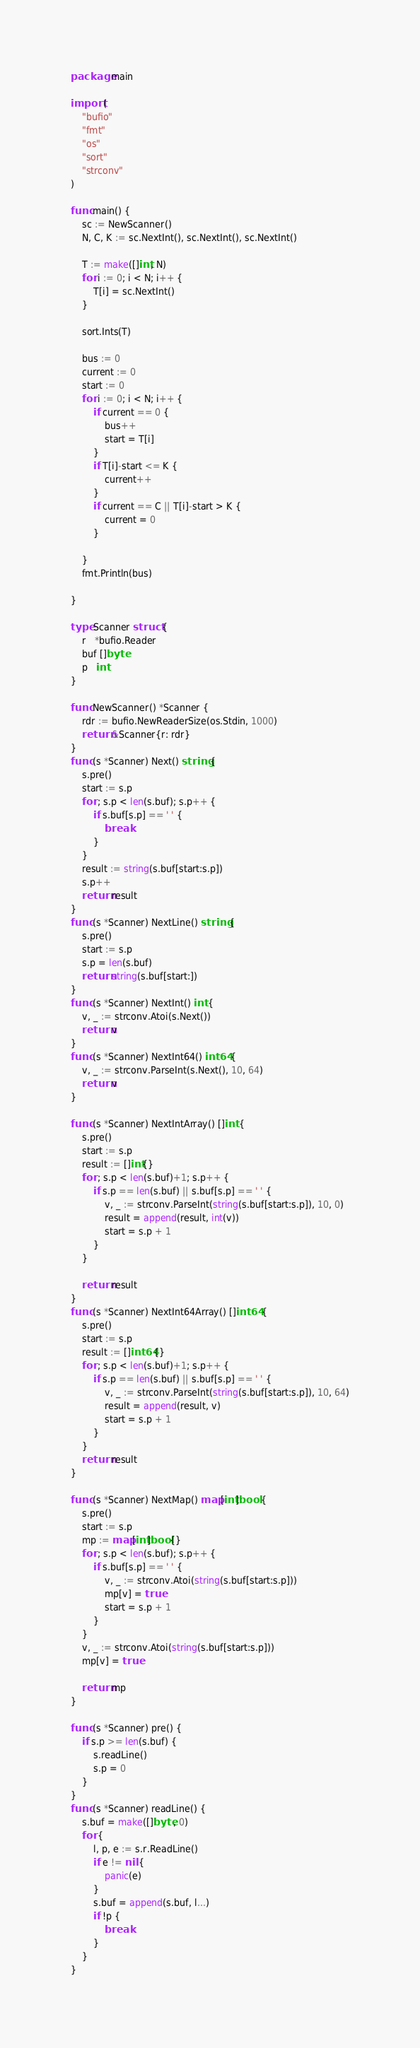<code> <loc_0><loc_0><loc_500><loc_500><_Go_>package main

import (
	"bufio"
	"fmt"
	"os"
	"sort"
	"strconv"
)

func main() {
	sc := NewScanner()
	N, C, K := sc.NextInt(), sc.NextInt(), sc.NextInt()

	T := make([]int, N)
	for i := 0; i < N; i++ {
		T[i] = sc.NextInt()
	}

	sort.Ints(T)

	bus := 0
	current := 0
	start := 0
	for i := 0; i < N; i++ {
		if current == 0 {
			bus++
			start = T[i]
		}
		if T[i]-start <= K {
			current++
		}
		if current == C || T[i]-start > K {
			current = 0
		}

	}
	fmt.Println(bus)

}

type Scanner struct {
	r   *bufio.Reader
	buf []byte
	p   int
}

func NewScanner() *Scanner {
	rdr := bufio.NewReaderSize(os.Stdin, 1000)
	return &Scanner{r: rdr}
}
func (s *Scanner) Next() string {
	s.pre()
	start := s.p
	for ; s.p < len(s.buf); s.p++ {
		if s.buf[s.p] == ' ' {
			break
		}
	}
	result := string(s.buf[start:s.p])
	s.p++
	return result
}
func (s *Scanner) NextLine() string {
	s.pre()
	start := s.p
	s.p = len(s.buf)
	return string(s.buf[start:])
}
func (s *Scanner) NextInt() int {
	v, _ := strconv.Atoi(s.Next())
	return v
}
func (s *Scanner) NextInt64() int64 {
	v, _ := strconv.ParseInt(s.Next(), 10, 64)
	return v
}

func (s *Scanner) NextIntArray() []int {
	s.pre()
	start := s.p
	result := []int{}
	for ; s.p < len(s.buf)+1; s.p++ {
		if s.p == len(s.buf) || s.buf[s.p] == ' ' {
			v, _ := strconv.ParseInt(string(s.buf[start:s.p]), 10, 0)
			result = append(result, int(v))
			start = s.p + 1
		}
	}

	return result
}
func (s *Scanner) NextInt64Array() []int64 {
	s.pre()
	start := s.p
	result := []int64{}
	for ; s.p < len(s.buf)+1; s.p++ {
		if s.p == len(s.buf) || s.buf[s.p] == ' ' {
			v, _ := strconv.ParseInt(string(s.buf[start:s.p]), 10, 64)
			result = append(result, v)
			start = s.p + 1
		}
	}
	return result
}

func (s *Scanner) NextMap() map[int]bool {
	s.pre()
	start := s.p
	mp := map[int]bool{}
	for ; s.p < len(s.buf); s.p++ {
		if s.buf[s.p] == ' ' {
			v, _ := strconv.Atoi(string(s.buf[start:s.p]))
			mp[v] = true
			start = s.p + 1
		}
	}
	v, _ := strconv.Atoi(string(s.buf[start:s.p]))
	mp[v] = true

	return mp
}

func (s *Scanner) pre() {
	if s.p >= len(s.buf) {
		s.readLine()
		s.p = 0
	}
}
func (s *Scanner) readLine() {
	s.buf = make([]byte, 0)
	for {
		l, p, e := s.r.ReadLine()
		if e != nil {
			panic(e)
		}
		s.buf = append(s.buf, l...)
		if !p {
			break
		}
	}
}
</code> 